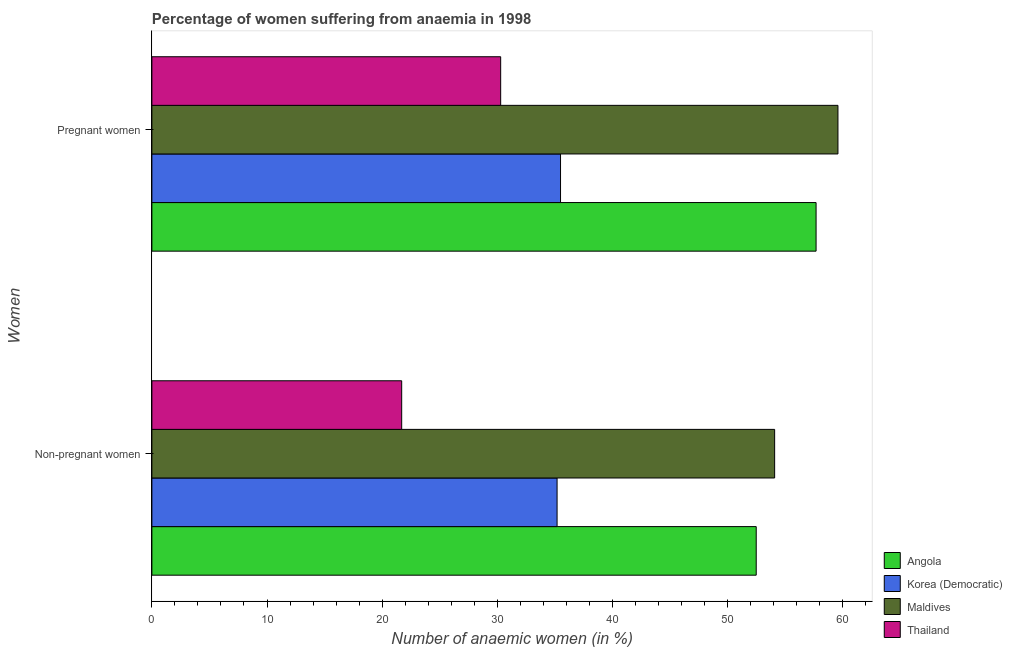Are the number of bars per tick equal to the number of legend labels?
Ensure brevity in your answer.  Yes. How many bars are there on the 2nd tick from the top?
Provide a succinct answer. 4. What is the label of the 1st group of bars from the top?
Give a very brief answer. Pregnant women. What is the percentage of non-pregnant anaemic women in Korea (Democratic)?
Your answer should be compact. 35.2. Across all countries, what is the maximum percentage of non-pregnant anaemic women?
Offer a terse response. 54.1. Across all countries, what is the minimum percentage of pregnant anaemic women?
Your response must be concise. 30.3. In which country was the percentage of non-pregnant anaemic women maximum?
Provide a succinct answer. Maldives. In which country was the percentage of pregnant anaemic women minimum?
Provide a short and direct response. Thailand. What is the total percentage of pregnant anaemic women in the graph?
Make the answer very short. 183.1. What is the difference between the percentage of pregnant anaemic women in Maldives and that in Angola?
Offer a very short reply. 1.9. What is the difference between the percentage of pregnant anaemic women in Maldives and the percentage of non-pregnant anaemic women in Thailand?
Give a very brief answer. 37.9. What is the average percentage of pregnant anaemic women per country?
Provide a succinct answer. 45.78. What is the difference between the percentage of non-pregnant anaemic women and percentage of pregnant anaemic women in Angola?
Offer a very short reply. -5.2. What is the ratio of the percentage of non-pregnant anaemic women in Korea (Democratic) to that in Thailand?
Your answer should be compact. 1.62. Is the percentage of pregnant anaemic women in Korea (Democratic) less than that in Angola?
Give a very brief answer. Yes. In how many countries, is the percentage of pregnant anaemic women greater than the average percentage of pregnant anaemic women taken over all countries?
Make the answer very short. 2. What does the 4th bar from the top in Pregnant women represents?
Provide a succinct answer. Angola. What does the 2nd bar from the bottom in Non-pregnant women represents?
Give a very brief answer. Korea (Democratic). Are all the bars in the graph horizontal?
Give a very brief answer. Yes. How many countries are there in the graph?
Your answer should be very brief. 4. What is the difference between two consecutive major ticks on the X-axis?
Provide a short and direct response. 10. Are the values on the major ticks of X-axis written in scientific E-notation?
Your response must be concise. No. Does the graph contain any zero values?
Give a very brief answer. No. Does the graph contain grids?
Give a very brief answer. No. What is the title of the graph?
Offer a terse response. Percentage of women suffering from anaemia in 1998. Does "Marshall Islands" appear as one of the legend labels in the graph?
Your answer should be very brief. No. What is the label or title of the X-axis?
Provide a short and direct response. Number of anaemic women (in %). What is the label or title of the Y-axis?
Give a very brief answer. Women. What is the Number of anaemic women (in %) in Angola in Non-pregnant women?
Make the answer very short. 52.5. What is the Number of anaemic women (in %) in Korea (Democratic) in Non-pregnant women?
Offer a terse response. 35.2. What is the Number of anaemic women (in %) of Maldives in Non-pregnant women?
Offer a terse response. 54.1. What is the Number of anaemic women (in %) in Thailand in Non-pregnant women?
Your answer should be very brief. 21.7. What is the Number of anaemic women (in %) of Angola in Pregnant women?
Offer a very short reply. 57.7. What is the Number of anaemic women (in %) in Korea (Democratic) in Pregnant women?
Give a very brief answer. 35.5. What is the Number of anaemic women (in %) of Maldives in Pregnant women?
Ensure brevity in your answer.  59.6. What is the Number of anaemic women (in %) in Thailand in Pregnant women?
Your answer should be compact. 30.3. Across all Women, what is the maximum Number of anaemic women (in %) of Angola?
Your answer should be compact. 57.7. Across all Women, what is the maximum Number of anaemic women (in %) of Korea (Democratic)?
Your answer should be compact. 35.5. Across all Women, what is the maximum Number of anaemic women (in %) in Maldives?
Give a very brief answer. 59.6. Across all Women, what is the maximum Number of anaemic women (in %) in Thailand?
Keep it short and to the point. 30.3. Across all Women, what is the minimum Number of anaemic women (in %) of Angola?
Give a very brief answer. 52.5. Across all Women, what is the minimum Number of anaemic women (in %) of Korea (Democratic)?
Your response must be concise. 35.2. Across all Women, what is the minimum Number of anaemic women (in %) of Maldives?
Keep it short and to the point. 54.1. Across all Women, what is the minimum Number of anaemic women (in %) of Thailand?
Give a very brief answer. 21.7. What is the total Number of anaemic women (in %) of Angola in the graph?
Your answer should be compact. 110.2. What is the total Number of anaemic women (in %) in Korea (Democratic) in the graph?
Offer a terse response. 70.7. What is the total Number of anaemic women (in %) in Maldives in the graph?
Your answer should be very brief. 113.7. What is the difference between the Number of anaemic women (in %) of Angola in Non-pregnant women and that in Pregnant women?
Offer a terse response. -5.2. What is the difference between the Number of anaemic women (in %) in Maldives in Non-pregnant women and that in Pregnant women?
Ensure brevity in your answer.  -5.5. What is the difference between the Number of anaemic women (in %) in Angola in Non-pregnant women and the Number of anaemic women (in %) in Korea (Democratic) in Pregnant women?
Ensure brevity in your answer.  17. What is the difference between the Number of anaemic women (in %) in Angola in Non-pregnant women and the Number of anaemic women (in %) in Thailand in Pregnant women?
Ensure brevity in your answer.  22.2. What is the difference between the Number of anaemic women (in %) in Korea (Democratic) in Non-pregnant women and the Number of anaemic women (in %) in Maldives in Pregnant women?
Ensure brevity in your answer.  -24.4. What is the difference between the Number of anaemic women (in %) of Korea (Democratic) in Non-pregnant women and the Number of anaemic women (in %) of Thailand in Pregnant women?
Provide a short and direct response. 4.9. What is the difference between the Number of anaemic women (in %) in Maldives in Non-pregnant women and the Number of anaemic women (in %) in Thailand in Pregnant women?
Ensure brevity in your answer.  23.8. What is the average Number of anaemic women (in %) of Angola per Women?
Your answer should be very brief. 55.1. What is the average Number of anaemic women (in %) of Korea (Democratic) per Women?
Your response must be concise. 35.35. What is the average Number of anaemic women (in %) of Maldives per Women?
Keep it short and to the point. 56.85. What is the difference between the Number of anaemic women (in %) of Angola and Number of anaemic women (in %) of Korea (Democratic) in Non-pregnant women?
Ensure brevity in your answer.  17.3. What is the difference between the Number of anaemic women (in %) in Angola and Number of anaemic women (in %) in Thailand in Non-pregnant women?
Provide a succinct answer. 30.8. What is the difference between the Number of anaemic women (in %) in Korea (Democratic) and Number of anaemic women (in %) in Maldives in Non-pregnant women?
Your answer should be compact. -18.9. What is the difference between the Number of anaemic women (in %) in Maldives and Number of anaemic women (in %) in Thailand in Non-pregnant women?
Ensure brevity in your answer.  32.4. What is the difference between the Number of anaemic women (in %) of Angola and Number of anaemic women (in %) of Korea (Democratic) in Pregnant women?
Make the answer very short. 22.2. What is the difference between the Number of anaemic women (in %) in Angola and Number of anaemic women (in %) in Thailand in Pregnant women?
Offer a very short reply. 27.4. What is the difference between the Number of anaemic women (in %) in Korea (Democratic) and Number of anaemic women (in %) in Maldives in Pregnant women?
Your answer should be compact. -24.1. What is the difference between the Number of anaemic women (in %) in Korea (Democratic) and Number of anaemic women (in %) in Thailand in Pregnant women?
Give a very brief answer. 5.2. What is the difference between the Number of anaemic women (in %) of Maldives and Number of anaemic women (in %) of Thailand in Pregnant women?
Your answer should be very brief. 29.3. What is the ratio of the Number of anaemic women (in %) in Angola in Non-pregnant women to that in Pregnant women?
Your response must be concise. 0.91. What is the ratio of the Number of anaemic women (in %) of Maldives in Non-pregnant women to that in Pregnant women?
Offer a terse response. 0.91. What is the ratio of the Number of anaemic women (in %) in Thailand in Non-pregnant women to that in Pregnant women?
Offer a terse response. 0.72. What is the difference between the highest and the second highest Number of anaemic women (in %) of Maldives?
Your answer should be very brief. 5.5. What is the difference between the highest and the second highest Number of anaemic women (in %) of Thailand?
Your response must be concise. 8.6. What is the difference between the highest and the lowest Number of anaemic women (in %) of Angola?
Offer a very short reply. 5.2. What is the difference between the highest and the lowest Number of anaemic women (in %) in Korea (Democratic)?
Provide a succinct answer. 0.3. 